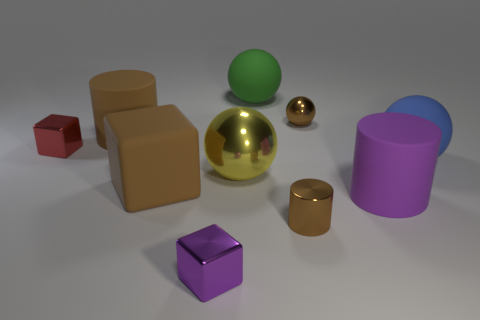What is the shape of the small brown object that is behind the matte cylinder that is on the left side of the tiny purple block?
Keep it short and to the point. Sphere. How big is the red thing?
Provide a short and direct response. Small. There is a red shiny thing; what shape is it?
Make the answer very short. Cube. Is the shape of the blue thing the same as the small brown metal thing that is in front of the big yellow object?
Your response must be concise. No. There is a big green matte thing that is on the right side of the brown matte cylinder; is its shape the same as the yellow metallic thing?
Make the answer very short. Yes. How many metal objects are both behind the big brown matte cube and on the left side of the green thing?
Your answer should be compact. 2. How many other things are there of the same size as the yellow object?
Provide a short and direct response. 5. Is the number of big objects to the left of the large brown matte cylinder the same as the number of yellow metal spheres?
Provide a succinct answer. No. Does the cube in front of the tiny brown metal cylinder have the same color as the big rubber cylinder that is in front of the big blue rubber ball?
Provide a succinct answer. Yes. What is the brown thing that is both to the right of the brown block and behind the yellow metallic sphere made of?
Keep it short and to the point. Metal. 